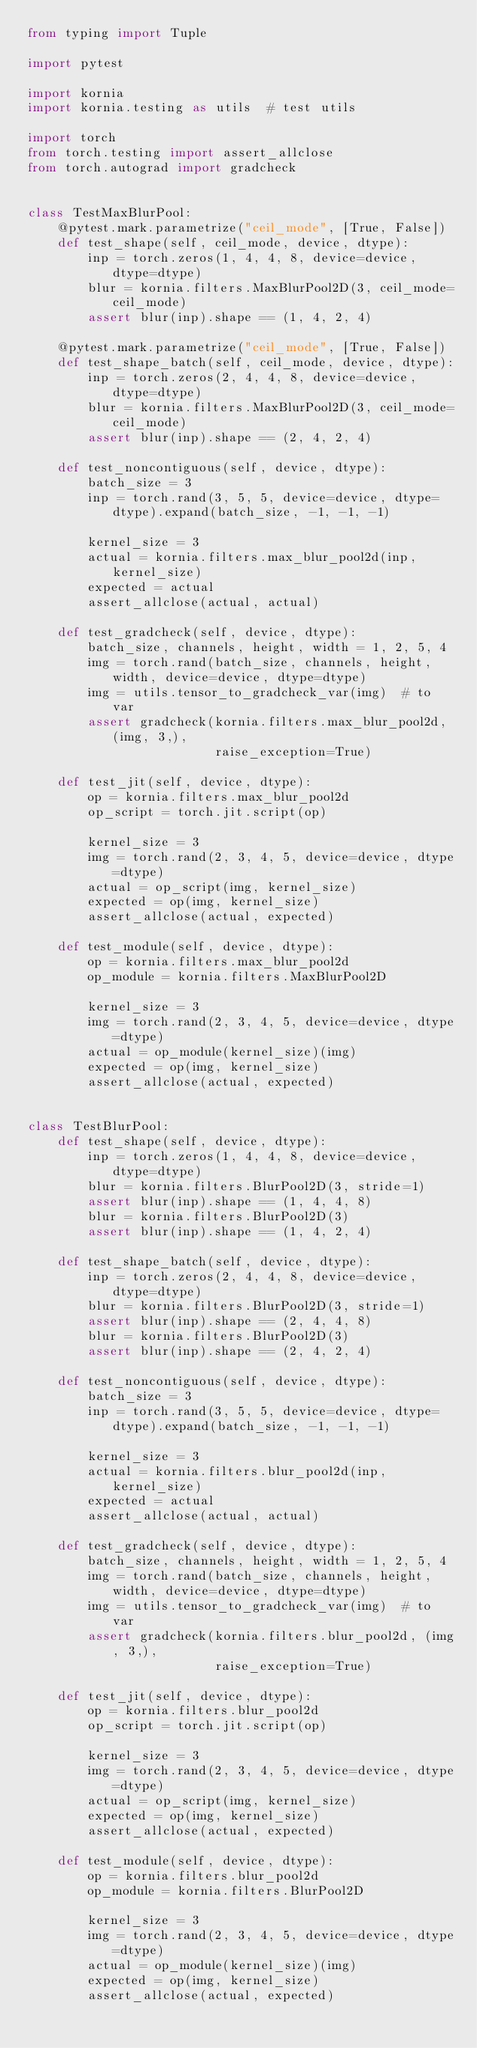<code> <loc_0><loc_0><loc_500><loc_500><_Python_>from typing import Tuple

import pytest

import kornia
import kornia.testing as utils  # test utils

import torch
from torch.testing import assert_allclose
from torch.autograd import gradcheck


class TestMaxBlurPool:
    @pytest.mark.parametrize("ceil_mode", [True, False])
    def test_shape(self, ceil_mode, device, dtype):
        inp = torch.zeros(1, 4, 4, 8, device=device, dtype=dtype)
        blur = kornia.filters.MaxBlurPool2D(3, ceil_mode=ceil_mode)
        assert blur(inp).shape == (1, 4, 2, 4)

    @pytest.mark.parametrize("ceil_mode", [True, False])
    def test_shape_batch(self, ceil_mode, device, dtype):
        inp = torch.zeros(2, 4, 4, 8, device=device, dtype=dtype)
        blur = kornia.filters.MaxBlurPool2D(3, ceil_mode=ceil_mode)
        assert blur(inp).shape == (2, 4, 2, 4)

    def test_noncontiguous(self, device, dtype):
        batch_size = 3
        inp = torch.rand(3, 5, 5, device=device, dtype=dtype).expand(batch_size, -1, -1, -1)

        kernel_size = 3
        actual = kornia.filters.max_blur_pool2d(inp, kernel_size)
        expected = actual
        assert_allclose(actual, actual)

    def test_gradcheck(self, device, dtype):
        batch_size, channels, height, width = 1, 2, 5, 4
        img = torch.rand(batch_size, channels, height, width, device=device, dtype=dtype)
        img = utils.tensor_to_gradcheck_var(img)  # to var
        assert gradcheck(kornia.filters.max_blur_pool2d, (img, 3,),
                         raise_exception=True)

    def test_jit(self, device, dtype):
        op = kornia.filters.max_blur_pool2d
        op_script = torch.jit.script(op)

        kernel_size = 3
        img = torch.rand(2, 3, 4, 5, device=device, dtype=dtype)
        actual = op_script(img, kernel_size)
        expected = op(img, kernel_size)
        assert_allclose(actual, expected)

    def test_module(self, device, dtype):
        op = kornia.filters.max_blur_pool2d
        op_module = kornia.filters.MaxBlurPool2D

        kernel_size = 3
        img = torch.rand(2, 3, 4, 5, device=device, dtype=dtype)
        actual = op_module(kernel_size)(img)
        expected = op(img, kernel_size)
        assert_allclose(actual, expected)


class TestBlurPool:
    def test_shape(self, device, dtype):
        inp = torch.zeros(1, 4, 4, 8, device=device, dtype=dtype)
        blur = kornia.filters.BlurPool2D(3, stride=1)
        assert blur(inp).shape == (1, 4, 4, 8)
        blur = kornia.filters.BlurPool2D(3)
        assert blur(inp).shape == (1, 4, 2, 4)

    def test_shape_batch(self, device, dtype):
        inp = torch.zeros(2, 4, 4, 8, device=device, dtype=dtype)
        blur = kornia.filters.BlurPool2D(3, stride=1)
        assert blur(inp).shape == (2, 4, 4, 8)
        blur = kornia.filters.BlurPool2D(3)
        assert blur(inp).shape == (2, 4, 2, 4)

    def test_noncontiguous(self, device, dtype):
        batch_size = 3
        inp = torch.rand(3, 5, 5, device=device, dtype=dtype).expand(batch_size, -1, -1, -1)

        kernel_size = 3
        actual = kornia.filters.blur_pool2d(inp, kernel_size)
        expected = actual
        assert_allclose(actual, actual)

    def test_gradcheck(self, device, dtype):
        batch_size, channels, height, width = 1, 2, 5, 4
        img = torch.rand(batch_size, channels, height, width, device=device, dtype=dtype)
        img = utils.tensor_to_gradcheck_var(img)  # to var
        assert gradcheck(kornia.filters.blur_pool2d, (img, 3,),
                         raise_exception=True)

    def test_jit(self, device, dtype):
        op = kornia.filters.blur_pool2d
        op_script = torch.jit.script(op)

        kernel_size = 3
        img = torch.rand(2, 3, 4, 5, device=device, dtype=dtype)
        actual = op_script(img, kernel_size)
        expected = op(img, kernel_size)
        assert_allclose(actual, expected)

    def test_module(self, device, dtype):
        op = kornia.filters.blur_pool2d
        op_module = kornia.filters.BlurPool2D

        kernel_size = 3
        img = torch.rand(2, 3, 4, 5, device=device, dtype=dtype)
        actual = op_module(kernel_size)(img)
        expected = op(img, kernel_size)
        assert_allclose(actual, expected)
</code> 